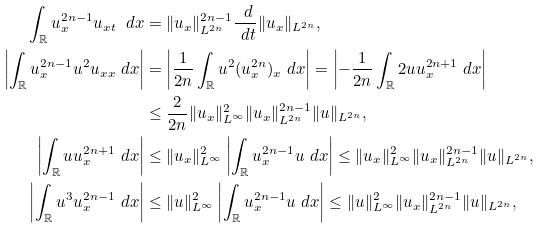Convert formula to latex. <formula><loc_0><loc_0><loc_500><loc_500>\int _ { \mathbb { R } } u _ { x } ^ { 2 n - 1 } u _ { x t } \ d x & = \| u _ { x } \| ^ { 2 n - 1 } _ { L ^ { 2 n } } \frac { \ d } { \ d t } \| u _ { x } \| _ { L ^ { 2 n } } , \\ \left | \int _ { \mathbb { R } } u _ { x } ^ { 2 n - 1 } u ^ { 2 } u _ { x x } \ d x \right | & = \left | \frac { 1 } { 2 n } \int _ { \mathbb { R } } u ^ { 2 } ( u _ { x } ^ { 2 n } ) _ { x } \ d x \right | = \left | - \frac { 1 } { 2 n } \int _ { \mathbb { R } } 2 u u _ { x } ^ { 2 n + 1 } \ d x \right | \\ & \leq \frac { 2 } { 2 n } \| u _ { x } \| ^ { 2 } _ { L ^ { \infty } } \| u _ { x } \| ^ { 2 n - 1 } _ { L ^ { 2 n } } \| u \| _ { L ^ { 2 n } } , \\ \left | \int _ { \mathbb { R } } u u _ { x } ^ { 2 n + 1 } \ d x \right | & \leq \| u _ { x } \| ^ { 2 } _ { L ^ { \infty } } \left | \int _ { \mathbb { R } } u _ { x } ^ { 2 n - 1 } u \ d x \right | \leq \| u _ { x } \| ^ { 2 } _ { L ^ { \infty } } \| u _ { x } \| ^ { 2 n - 1 } _ { L ^ { 2 n } } \| u \| _ { L ^ { 2 n } } , \\ \left | \int _ { \mathbb { R } } u ^ { 3 } u _ { x } ^ { 2 n - 1 } \ d x \right | & \leq \| u \| ^ { 2 } _ { L ^ { \infty } } \left | \int _ { \mathbb { R } } u _ { x } ^ { 2 n - 1 } u \ d x \right | \leq \| u \| ^ { 2 } _ { L ^ { \infty } } \| u _ { x } \| ^ { 2 n - 1 } _ { L ^ { 2 n } } \| u \| _ { L ^ { 2 n } } ,</formula> 